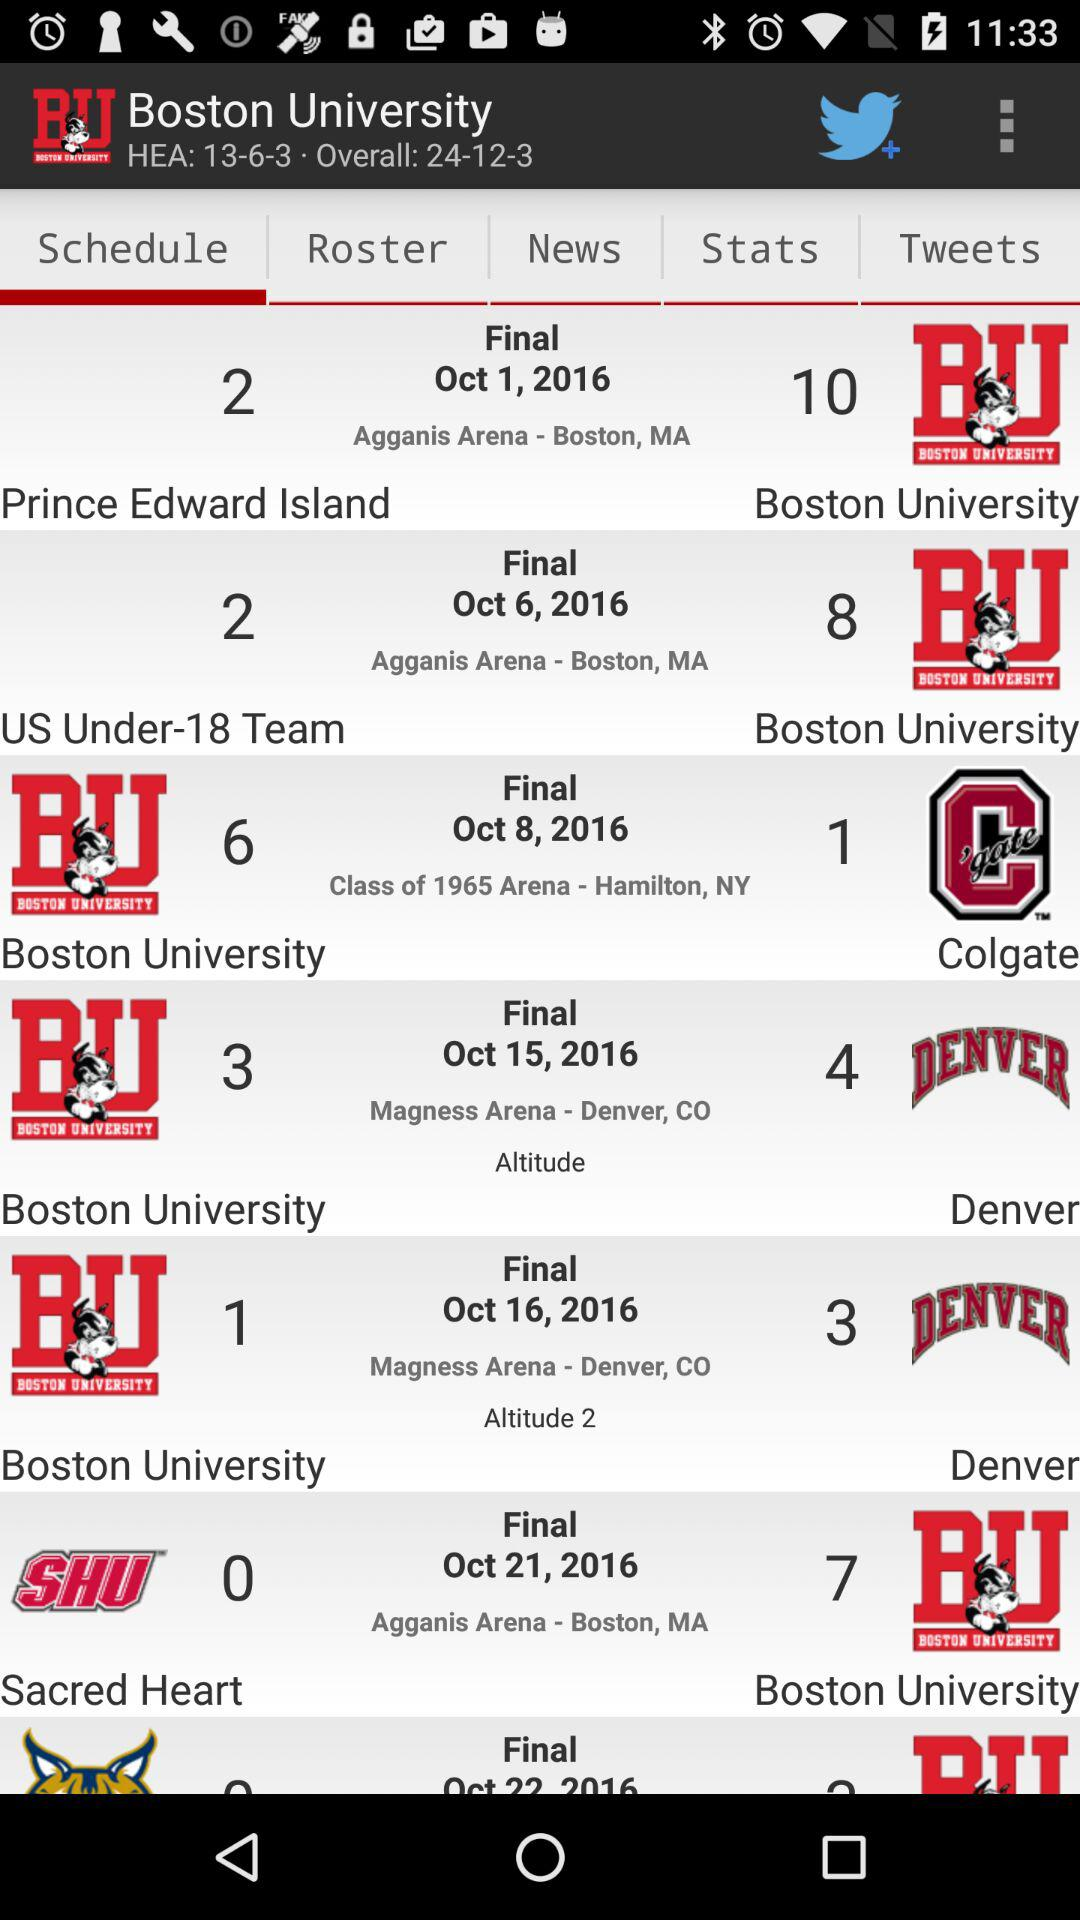Which tab is selected? The selected tab is "Schedule". 